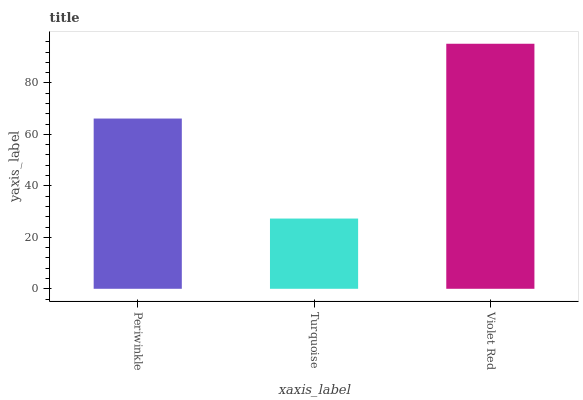Is Turquoise the minimum?
Answer yes or no. Yes. Is Violet Red the maximum?
Answer yes or no. Yes. Is Violet Red the minimum?
Answer yes or no. No. Is Turquoise the maximum?
Answer yes or no. No. Is Violet Red greater than Turquoise?
Answer yes or no. Yes. Is Turquoise less than Violet Red?
Answer yes or no. Yes. Is Turquoise greater than Violet Red?
Answer yes or no. No. Is Violet Red less than Turquoise?
Answer yes or no. No. Is Periwinkle the high median?
Answer yes or no. Yes. Is Periwinkle the low median?
Answer yes or no. Yes. Is Violet Red the high median?
Answer yes or no. No. Is Turquoise the low median?
Answer yes or no. No. 